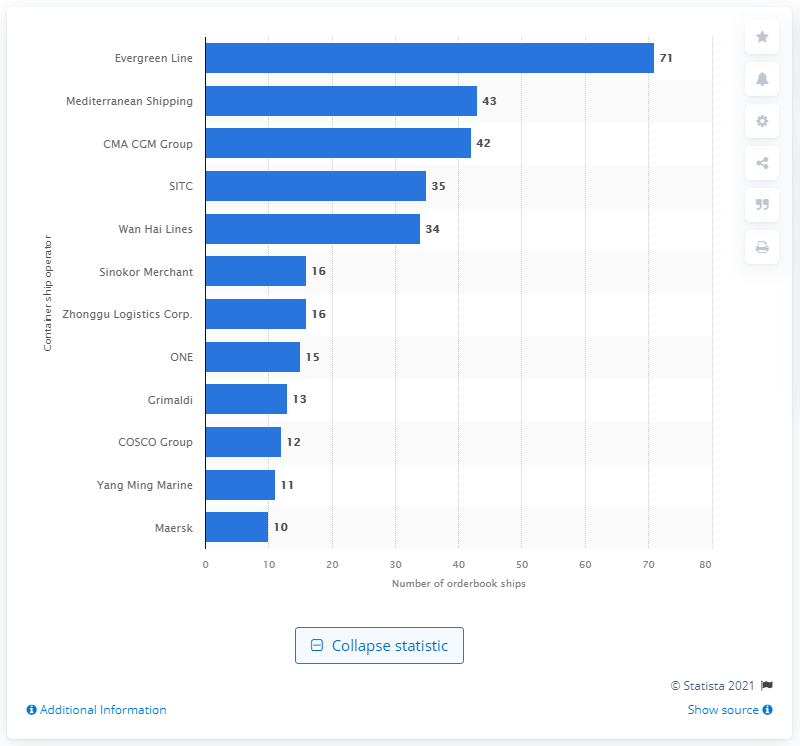Identify some key points in this picture. As of June 21, 2021, CMA CGM Group's order book contained 42 ships. As of June 21, 2021, the number of ships in Mediterranean Shipping Company's order book was 43. As of June 21, 2021, the Evergreen Line had the highest number of ships in its order book. 